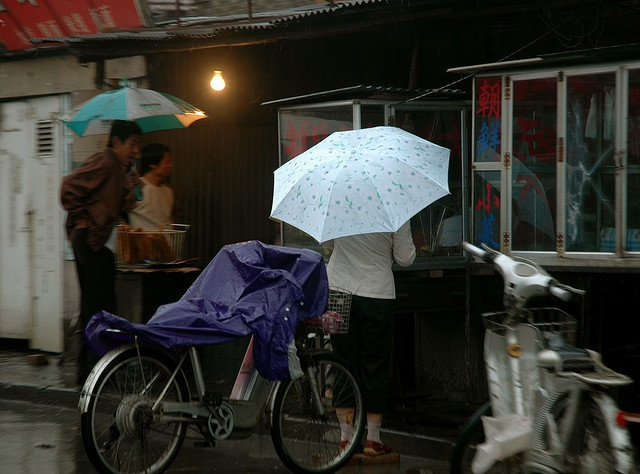Describe the objects in this image and their specific colors. I can see bicycle in maroon, black, and gray tones, motorcycle in maroon, black, gray, and darkgray tones, umbrella in maroon, lightblue, and darkgray tones, people in maroon, black, and gray tones, and people in maroon, black, and gray tones in this image. 